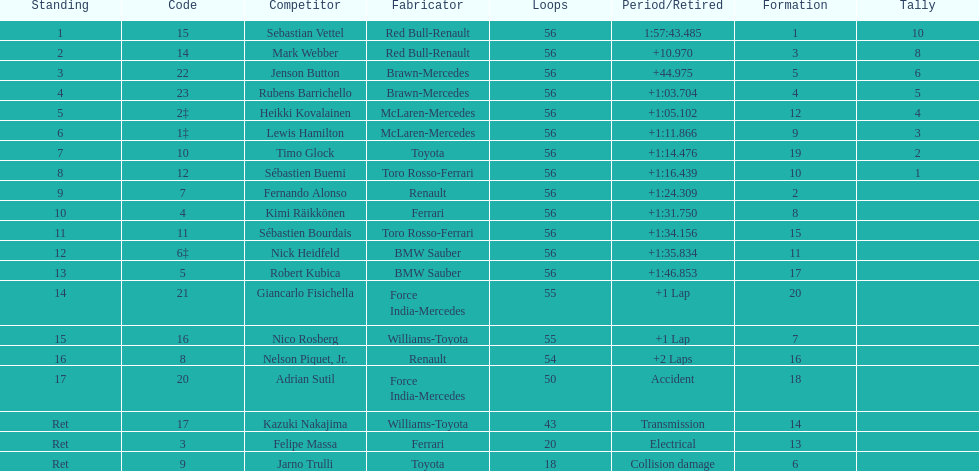How many drivers did not finish 56 laps? 7. 